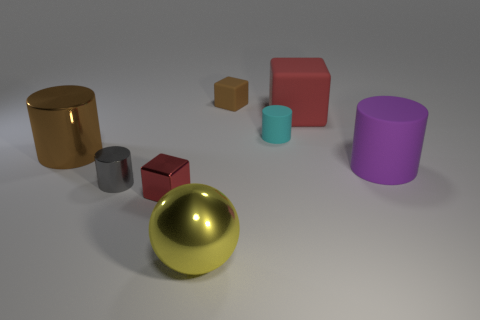Do the cube that is in front of the large purple thing and the red cube on the right side of the small rubber cylinder have the same size?
Your response must be concise. No. There is a thing that is both on the left side of the red matte cube and behind the cyan matte thing; what shape is it?
Make the answer very short. Cube. Is there a large cube that has the same material as the big red object?
Ensure brevity in your answer.  No. There is a tiny object that is the same color as the large rubber cube; what is it made of?
Offer a very short reply. Metal. Does the big cylinder on the right side of the yellow ball have the same material as the big sphere on the right side of the tiny shiny cylinder?
Ensure brevity in your answer.  No. Is the number of large objects greater than the number of small brown rubber objects?
Provide a short and direct response. Yes. The block right of the tiny cylinder that is behind the big cylinder to the right of the cyan matte cylinder is what color?
Your answer should be compact. Red. There is a small block on the right side of the red metal object; does it have the same color as the metal cylinder behind the purple matte cylinder?
Your answer should be very brief. Yes. There is a big object that is to the left of the small metal cylinder; how many tiny brown matte cubes are on the left side of it?
Offer a terse response. 0. Is there a small purple rubber object?
Ensure brevity in your answer.  No. 